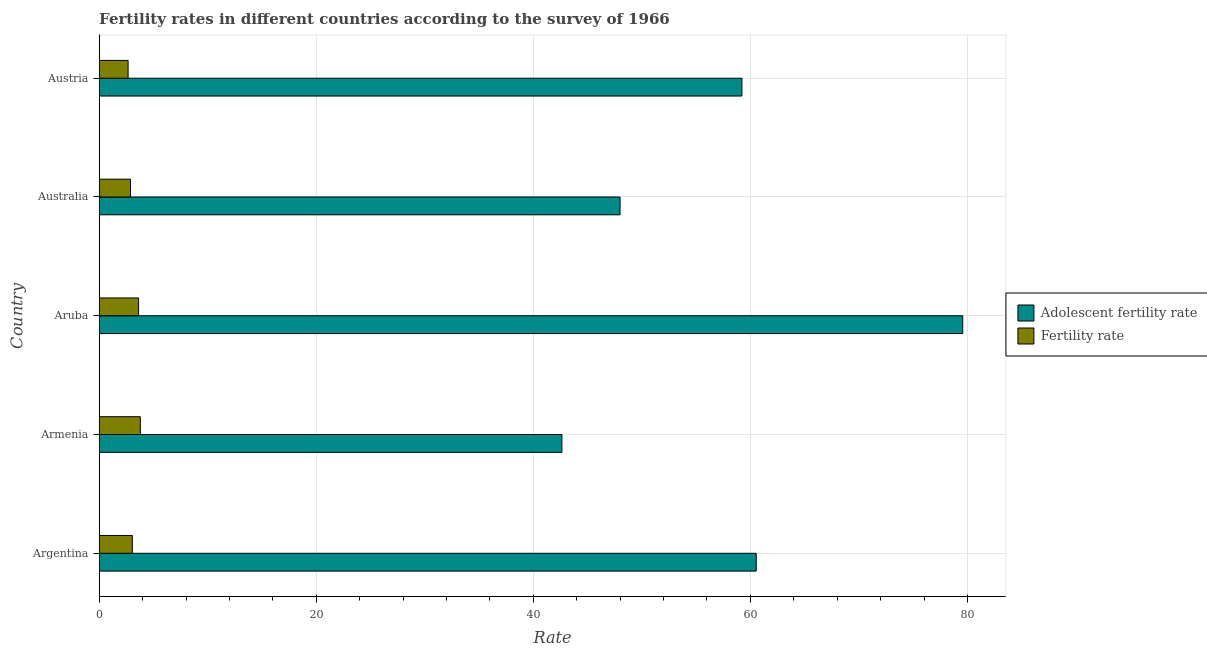Are the number of bars on each tick of the Y-axis equal?
Your answer should be very brief. Yes. How many bars are there on the 4th tick from the top?
Provide a succinct answer. 2. How many bars are there on the 3rd tick from the bottom?
Provide a short and direct response. 2. What is the label of the 3rd group of bars from the top?
Your answer should be very brief. Aruba. What is the adolescent fertility rate in Australia?
Your response must be concise. 47.99. Across all countries, what is the maximum adolescent fertility rate?
Give a very brief answer. 79.57. Across all countries, what is the minimum adolescent fertility rate?
Ensure brevity in your answer.  42.63. In which country was the fertility rate maximum?
Your response must be concise. Armenia. In which country was the adolescent fertility rate minimum?
Your answer should be compact. Armenia. What is the total fertility rate in the graph?
Your response must be concise. 16.01. What is the difference between the fertility rate in Armenia and that in Australia?
Ensure brevity in your answer.  0.91. What is the difference between the adolescent fertility rate in Australia and the fertility rate in Armenia?
Your response must be concise. 44.2. What is the average fertility rate per country?
Make the answer very short. 3.2. What is the difference between the adolescent fertility rate and fertility rate in Aruba?
Give a very brief answer. 75.94. In how many countries, is the adolescent fertility rate greater than 56 ?
Offer a very short reply. 3. What is the ratio of the fertility rate in Armenia to that in Australia?
Keep it short and to the point. 1.31. Is the fertility rate in Argentina less than that in Aruba?
Provide a short and direct response. Yes. What is the difference between the highest and the second highest adolescent fertility rate?
Keep it short and to the point. 19.03. What is the difference between the highest and the lowest fertility rate?
Keep it short and to the point. 1.13. Is the sum of the fertility rate in Armenia and Aruba greater than the maximum adolescent fertility rate across all countries?
Your response must be concise. No. What does the 1st bar from the top in Aruba represents?
Make the answer very short. Fertility rate. What does the 2nd bar from the bottom in Armenia represents?
Ensure brevity in your answer.  Fertility rate. How many bars are there?
Offer a very short reply. 10. What is the difference between two consecutive major ticks on the X-axis?
Give a very brief answer. 20. Are the values on the major ticks of X-axis written in scientific E-notation?
Your response must be concise. No. How many legend labels are there?
Offer a terse response. 2. How are the legend labels stacked?
Your answer should be compact. Vertical. What is the title of the graph?
Make the answer very short. Fertility rates in different countries according to the survey of 1966. Does "Chemicals" appear as one of the legend labels in the graph?
Provide a short and direct response. No. What is the label or title of the X-axis?
Provide a succinct answer. Rate. What is the Rate in Adolescent fertility rate in Argentina?
Provide a short and direct response. 60.54. What is the Rate in Fertility rate in Argentina?
Offer a terse response. 3.05. What is the Rate in Adolescent fertility rate in Armenia?
Keep it short and to the point. 42.63. What is the Rate of Fertility rate in Armenia?
Ensure brevity in your answer.  3.79. What is the Rate of Adolescent fertility rate in Aruba?
Ensure brevity in your answer.  79.57. What is the Rate of Fertility rate in Aruba?
Your answer should be compact. 3.62. What is the Rate in Adolescent fertility rate in Australia?
Your answer should be very brief. 47.99. What is the Rate in Fertility rate in Australia?
Offer a terse response. 2.88. What is the Rate in Adolescent fertility rate in Austria?
Offer a terse response. 59.22. What is the Rate in Fertility rate in Austria?
Provide a short and direct response. 2.66. Across all countries, what is the maximum Rate of Adolescent fertility rate?
Your answer should be compact. 79.57. Across all countries, what is the maximum Rate of Fertility rate?
Your answer should be compact. 3.79. Across all countries, what is the minimum Rate of Adolescent fertility rate?
Ensure brevity in your answer.  42.63. Across all countries, what is the minimum Rate of Fertility rate?
Your answer should be very brief. 2.66. What is the total Rate of Adolescent fertility rate in the graph?
Make the answer very short. 289.95. What is the total Rate in Fertility rate in the graph?
Your answer should be very brief. 16. What is the difference between the Rate in Adolescent fertility rate in Argentina and that in Armenia?
Your answer should be compact. 17.91. What is the difference between the Rate in Fertility rate in Argentina and that in Armenia?
Offer a very short reply. -0.74. What is the difference between the Rate in Adolescent fertility rate in Argentina and that in Aruba?
Provide a succinct answer. -19.03. What is the difference between the Rate in Fertility rate in Argentina and that in Aruba?
Keep it short and to the point. -0.57. What is the difference between the Rate in Adolescent fertility rate in Argentina and that in Australia?
Your response must be concise. 12.55. What is the difference between the Rate of Fertility rate in Argentina and that in Australia?
Provide a short and direct response. 0.17. What is the difference between the Rate in Adolescent fertility rate in Argentina and that in Austria?
Ensure brevity in your answer.  1.32. What is the difference between the Rate of Fertility rate in Argentina and that in Austria?
Ensure brevity in your answer.  0.39. What is the difference between the Rate of Adolescent fertility rate in Armenia and that in Aruba?
Make the answer very short. -36.93. What is the difference between the Rate in Fertility rate in Armenia and that in Aruba?
Give a very brief answer. 0.16. What is the difference between the Rate of Adolescent fertility rate in Armenia and that in Australia?
Provide a short and direct response. -5.36. What is the difference between the Rate in Fertility rate in Armenia and that in Australia?
Your answer should be very brief. 0.91. What is the difference between the Rate of Adolescent fertility rate in Armenia and that in Austria?
Your response must be concise. -16.59. What is the difference between the Rate of Fertility rate in Armenia and that in Austria?
Keep it short and to the point. 1.13. What is the difference between the Rate of Adolescent fertility rate in Aruba and that in Australia?
Provide a succinct answer. 31.58. What is the difference between the Rate of Fertility rate in Aruba and that in Australia?
Give a very brief answer. 0.74. What is the difference between the Rate in Adolescent fertility rate in Aruba and that in Austria?
Provide a succinct answer. 20.35. What is the difference between the Rate of Adolescent fertility rate in Australia and that in Austria?
Give a very brief answer. -11.23. What is the difference between the Rate in Fertility rate in Australia and that in Austria?
Your answer should be compact. 0.22. What is the difference between the Rate of Adolescent fertility rate in Argentina and the Rate of Fertility rate in Armenia?
Provide a short and direct response. 56.75. What is the difference between the Rate of Adolescent fertility rate in Argentina and the Rate of Fertility rate in Aruba?
Ensure brevity in your answer.  56.91. What is the difference between the Rate of Adolescent fertility rate in Argentina and the Rate of Fertility rate in Australia?
Keep it short and to the point. 57.66. What is the difference between the Rate of Adolescent fertility rate in Argentina and the Rate of Fertility rate in Austria?
Give a very brief answer. 57.88. What is the difference between the Rate of Adolescent fertility rate in Armenia and the Rate of Fertility rate in Aruba?
Give a very brief answer. 39.01. What is the difference between the Rate of Adolescent fertility rate in Armenia and the Rate of Fertility rate in Australia?
Ensure brevity in your answer.  39.75. What is the difference between the Rate in Adolescent fertility rate in Armenia and the Rate in Fertility rate in Austria?
Ensure brevity in your answer.  39.97. What is the difference between the Rate in Adolescent fertility rate in Aruba and the Rate in Fertility rate in Australia?
Keep it short and to the point. 76.68. What is the difference between the Rate in Adolescent fertility rate in Aruba and the Rate in Fertility rate in Austria?
Your response must be concise. 76.91. What is the difference between the Rate in Adolescent fertility rate in Australia and the Rate in Fertility rate in Austria?
Keep it short and to the point. 45.33. What is the average Rate of Adolescent fertility rate per country?
Your response must be concise. 57.99. What is the average Rate of Fertility rate per country?
Offer a terse response. 3.2. What is the difference between the Rate of Adolescent fertility rate and Rate of Fertility rate in Argentina?
Make the answer very short. 57.49. What is the difference between the Rate of Adolescent fertility rate and Rate of Fertility rate in Armenia?
Make the answer very short. 38.84. What is the difference between the Rate in Adolescent fertility rate and Rate in Fertility rate in Aruba?
Offer a terse response. 75.94. What is the difference between the Rate of Adolescent fertility rate and Rate of Fertility rate in Australia?
Provide a succinct answer. 45.11. What is the difference between the Rate of Adolescent fertility rate and Rate of Fertility rate in Austria?
Your answer should be very brief. 56.56. What is the ratio of the Rate in Adolescent fertility rate in Argentina to that in Armenia?
Provide a short and direct response. 1.42. What is the ratio of the Rate in Fertility rate in Argentina to that in Armenia?
Give a very brief answer. 0.81. What is the ratio of the Rate in Adolescent fertility rate in Argentina to that in Aruba?
Your answer should be compact. 0.76. What is the ratio of the Rate of Fertility rate in Argentina to that in Aruba?
Your response must be concise. 0.84. What is the ratio of the Rate of Adolescent fertility rate in Argentina to that in Australia?
Ensure brevity in your answer.  1.26. What is the ratio of the Rate in Fertility rate in Argentina to that in Australia?
Your answer should be very brief. 1.06. What is the ratio of the Rate of Adolescent fertility rate in Argentina to that in Austria?
Your response must be concise. 1.02. What is the ratio of the Rate of Fertility rate in Argentina to that in Austria?
Make the answer very short. 1.15. What is the ratio of the Rate of Adolescent fertility rate in Armenia to that in Aruba?
Your response must be concise. 0.54. What is the ratio of the Rate in Fertility rate in Armenia to that in Aruba?
Offer a very short reply. 1.04. What is the ratio of the Rate of Adolescent fertility rate in Armenia to that in Australia?
Ensure brevity in your answer.  0.89. What is the ratio of the Rate in Fertility rate in Armenia to that in Australia?
Provide a short and direct response. 1.31. What is the ratio of the Rate of Adolescent fertility rate in Armenia to that in Austria?
Your answer should be very brief. 0.72. What is the ratio of the Rate in Fertility rate in Armenia to that in Austria?
Offer a very short reply. 1.42. What is the ratio of the Rate in Adolescent fertility rate in Aruba to that in Australia?
Make the answer very short. 1.66. What is the ratio of the Rate of Fertility rate in Aruba to that in Australia?
Keep it short and to the point. 1.26. What is the ratio of the Rate of Adolescent fertility rate in Aruba to that in Austria?
Give a very brief answer. 1.34. What is the ratio of the Rate of Fertility rate in Aruba to that in Austria?
Keep it short and to the point. 1.36. What is the ratio of the Rate in Adolescent fertility rate in Australia to that in Austria?
Offer a terse response. 0.81. What is the ratio of the Rate of Fertility rate in Australia to that in Austria?
Provide a short and direct response. 1.08. What is the difference between the highest and the second highest Rate in Adolescent fertility rate?
Keep it short and to the point. 19.03. What is the difference between the highest and the second highest Rate of Fertility rate?
Your response must be concise. 0.16. What is the difference between the highest and the lowest Rate in Adolescent fertility rate?
Provide a short and direct response. 36.93. What is the difference between the highest and the lowest Rate of Fertility rate?
Offer a terse response. 1.13. 